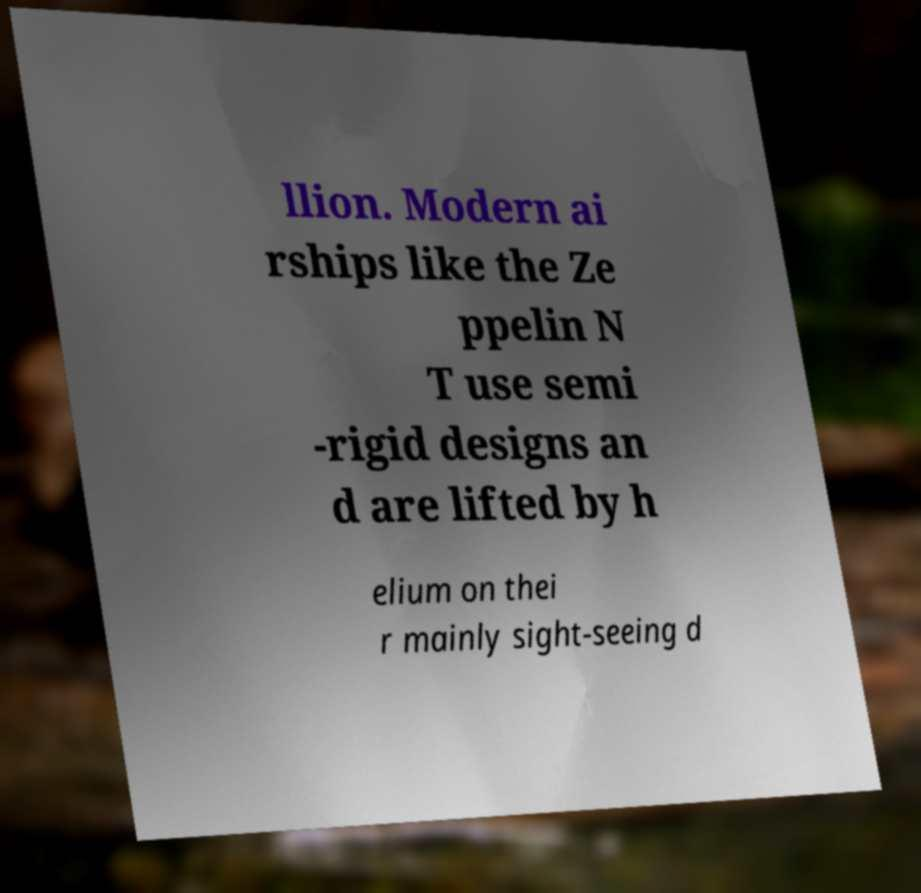Could you assist in decoding the text presented in this image and type it out clearly? llion. Modern ai rships like the Ze ppelin N T use semi -rigid designs an d are lifted by h elium on thei r mainly sight-seeing d 